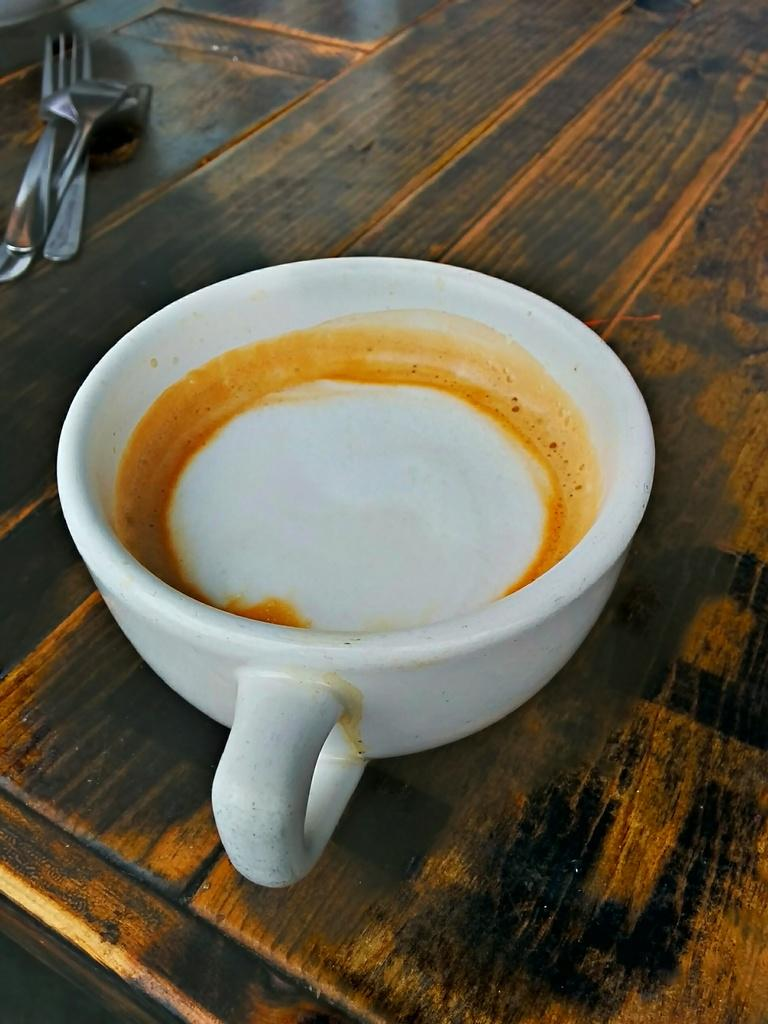What is in the image that people might use to drink a hot beverage? There is a coffee cup in the image. What utensils can be seen in the image? Spoons are visible in the image. On what surface are the spoons placed? The spoons are placed on a wooden surface. What type of marble is used to decorate the coffee cup in the image? There is no marble present in the image, and the coffee cup does not appear to be decorated with any marble. 